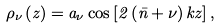Convert formula to latex. <formula><loc_0><loc_0><loc_500><loc_500>\rho _ { \nu } \left ( z \right ) = a _ { \nu } \cos \left [ 2 \left ( \bar { n } + \nu \right ) k z \right ] ,</formula> 